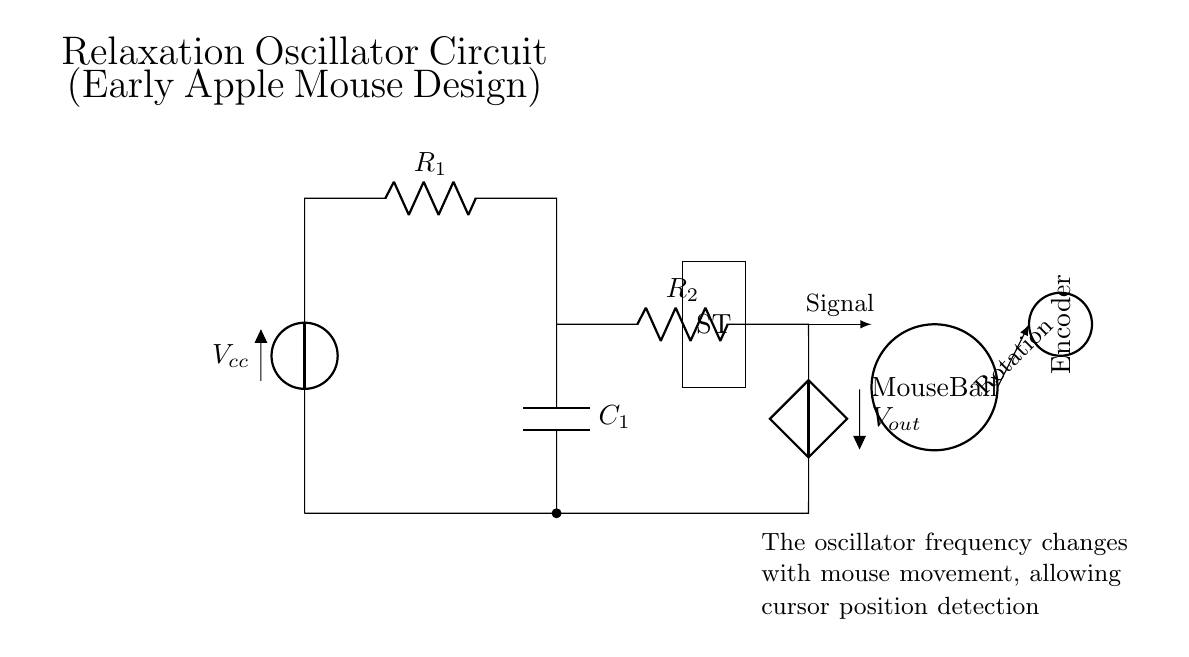What type of components are present in this circuit? The circuit includes a voltage source, resistors, a capacitor, and a Schmitt Trigger. Each of these components plays a role in the function of the oscillator.
Answer: voltage source, resistors, capacitor, Schmitt Trigger What is the function of the Schmitt Trigger in this circuit? The Schmitt Trigger converts the analog voltage signal from the capacitor into a digital signal, providing hysteresis which is important for stable switching between states.
Answer: digital signal conversion What determines the frequency of the oscillator? The frequency is determined by the values of the resistors R1 and R2 and the capacitor C1, which together set the charging and discharging times in the relaxation oscillator configuration.
Answer: R1, R2, and C1 values How does the mouse movement affect the oscillator frequency? When the mouse moves, the encoder wheel rotates, which alters the output signal frequency of the oscillator, allowing for cursor position detection based on the rate of movement.
Answer: changes in output signal frequency What happens to the output signal when the voltage across the capacitor reaches a specific threshold? When the voltage across the capacitor C1 reaches a certain threshold, the Schmitt Trigger switches its output state, causing the output voltage to toggle between high and low, which is the essence of the oscillator's function.
Answer: toggles output state What role does the mouse ball play in the overall circuit? The mouse ball interacts with the encoder wheel and translates the physical movement into rotational motion, which in turn influences the operation of the oscillator by changing the frequency of the output signal.
Answer: converts motion into signal changes 